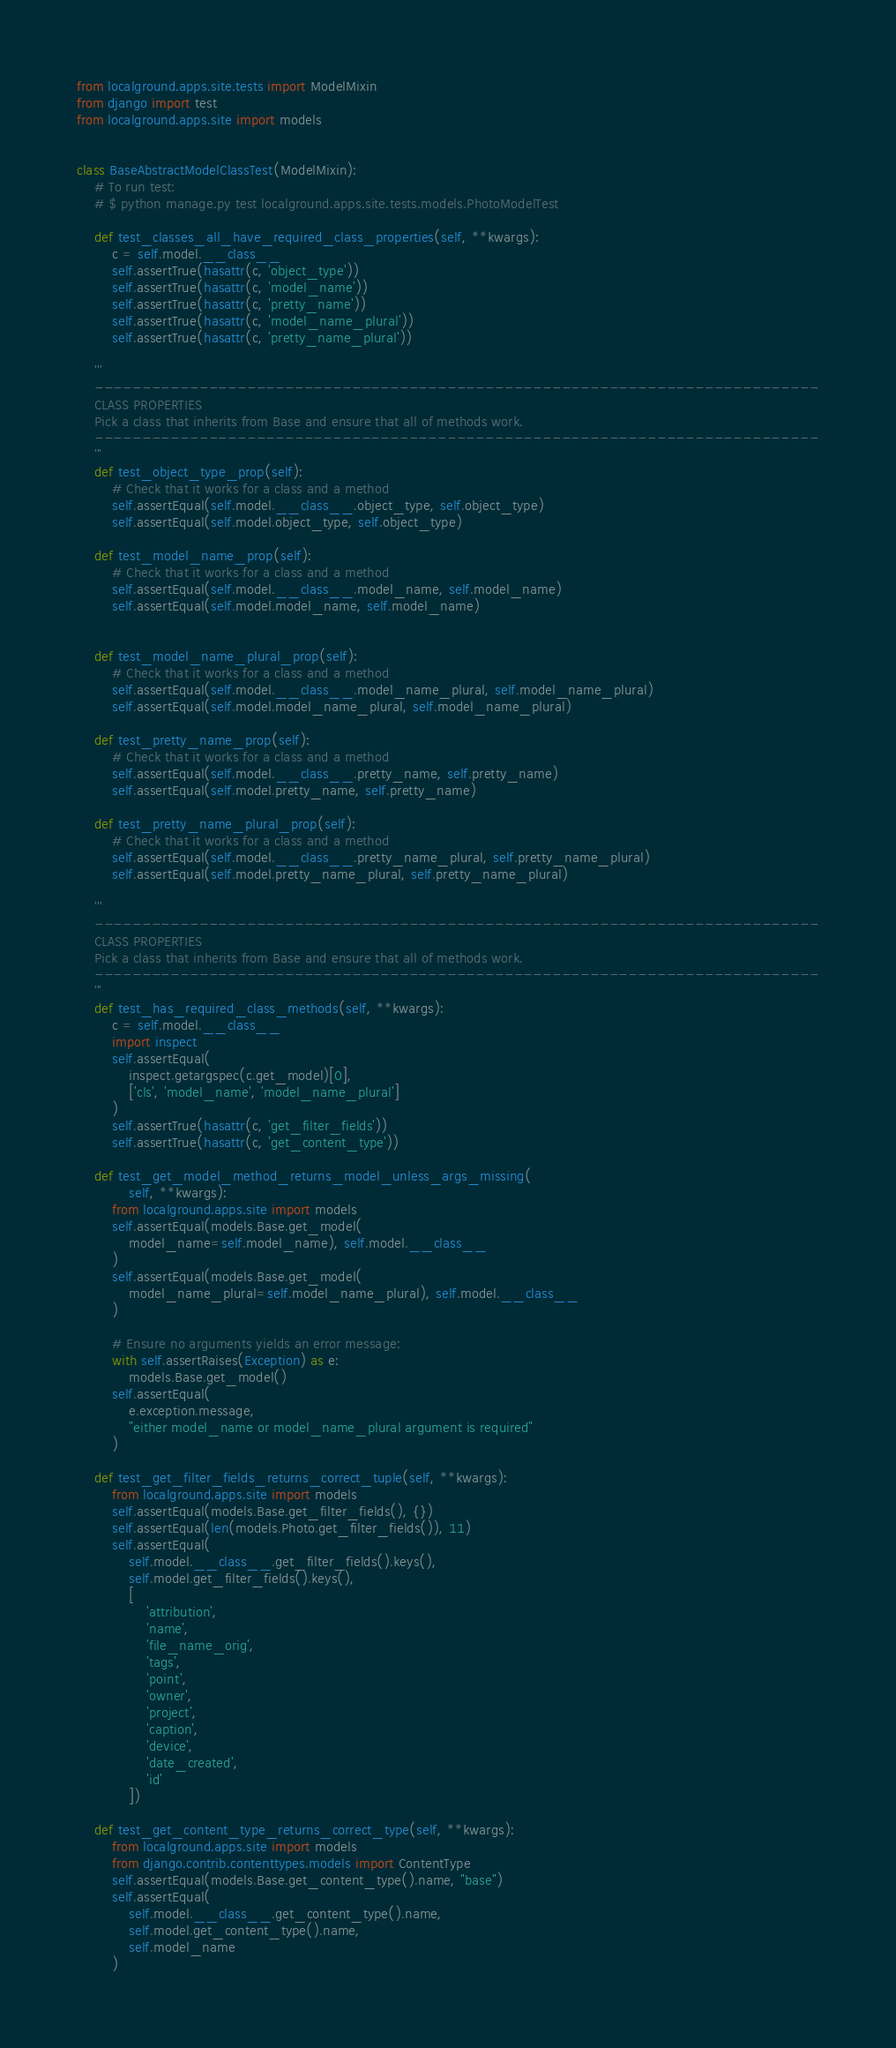Convert code to text. <code><loc_0><loc_0><loc_500><loc_500><_Python_>from localground.apps.site.tests import ModelMixin
from django import test
from localground.apps.site import models


class BaseAbstractModelClassTest(ModelMixin):
    # To run test:
    # $ python manage.py test localground.apps.site.tests.models.PhotoModelTest

    def test_classes_all_have_required_class_properties(self, **kwargs):
        c = self.model.__class__
        self.assertTrue(hasattr(c, 'object_type'))
        self.assertTrue(hasattr(c, 'model_name'))
        self.assertTrue(hasattr(c, 'pretty_name'))
        self.assertTrue(hasattr(c, 'model_name_plural'))
        self.assertTrue(hasattr(c, 'pretty_name_plural'))

    '''
    ----------------------------------------------------------------------------
    CLASS PROPERTIES
    Pick a class that inherits from Base and ensure that all of methods work.
    ----------------------------------------------------------------------------
    '''
    def test_object_type_prop(self):
        # Check that it works for a class and a method
        self.assertEqual(self.model.__class__.object_type, self.object_type)
        self.assertEqual(self.model.object_type, self.object_type)

    def test_model_name_prop(self):
        # Check that it works for a class and a method
        self.assertEqual(self.model.__class__.model_name, self.model_name)
        self.assertEqual(self.model.model_name, self.model_name)


    def test_model_name_plural_prop(self):
        # Check that it works for a class and a method
        self.assertEqual(self.model.__class__.model_name_plural, self.model_name_plural)
        self.assertEqual(self.model.model_name_plural, self.model_name_plural)

    def test_pretty_name_prop(self):
        # Check that it works for a class and a method
        self.assertEqual(self.model.__class__.pretty_name, self.pretty_name)
        self.assertEqual(self.model.pretty_name, self.pretty_name)

    def test_pretty_name_plural_prop(self):
        # Check that it works for a class and a method
        self.assertEqual(self.model.__class__.pretty_name_plural, self.pretty_name_plural)
        self.assertEqual(self.model.pretty_name_plural, self.pretty_name_plural)

    '''
    ----------------------------------------------------------------------------
    CLASS PROPERTIES
    Pick a class that inherits from Base and ensure that all of methods work.
    ----------------------------------------------------------------------------
    '''
    def test_has_required_class_methods(self, **kwargs):
        c = self.model.__class__
        import inspect
        self.assertEqual(
            inspect.getargspec(c.get_model)[0],
            ['cls', 'model_name', 'model_name_plural']
        )
        self.assertTrue(hasattr(c, 'get_filter_fields'))
        self.assertTrue(hasattr(c, 'get_content_type'))

    def test_get_model_method_returns_model_unless_args_missing(
            self, **kwargs):
        from localground.apps.site import models
        self.assertEqual(models.Base.get_model(
            model_name=self.model_name), self.model.__class__
        )
        self.assertEqual(models.Base.get_model(
            model_name_plural=self.model_name_plural), self.model.__class__
        )

        # Ensure no arguments yields an error message:
        with self.assertRaises(Exception) as e:
            models.Base.get_model()
        self.assertEqual(
            e.exception.message,
            "either model_name or model_name_plural argument is required"
        )

    def test_get_filter_fields_returns_correct_tuple(self, **kwargs):
        from localground.apps.site import models
        self.assertEqual(models.Base.get_filter_fields(), {})
        self.assertEqual(len(models.Photo.get_filter_fields()), 11)
        self.assertEqual(
            self.model.__class__.get_filter_fields().keys(),
            self.model.get_filter_fields().keys(),
            [
                'attribution',
                'name',
                'file_name_orig',
                'tags',
                'point',
                'owner',
                'project',
                'caption',
                'device',
                'date_created',
                'id'
            ])

    def test_get_content_type_returns_correct_type(self, **kwargs):
        from localground.apps.site import models
        from django.contrib.contenttypes.models import ContentType
        self.assertEqual(models.Base.get_content_type().name, "base")
        self.assertEqual(
            self.model.__class__.get_content_type().name,
            self.model.get_content_type().name,
            self.model_name
        )
</code> 